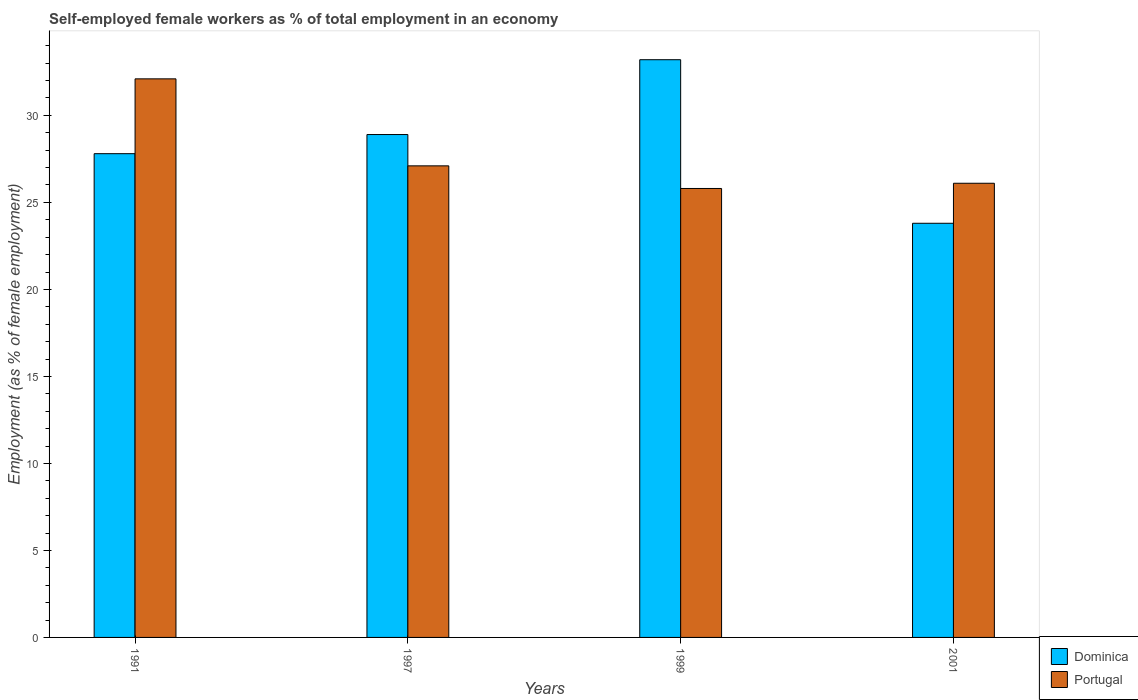Are the number of bars per tick equal to the number of legend labels?
Keep it short and to the point. Yes. Are the number of bars on each tick of the X-axis equal?
Provide a succinct answer. Yes. How many bars are there on the 2nd tick from the left?
Provide a succinct answer. 2. What is the label of the 3rd group of bars from the left?
Provide a succinct answer. 1999. What is the percentage of self-employed female workers in Dominica in 1997?
Offer a very short reply. 28.9. Across all years, what is the maximum percentage of self-employed female workers in Portugal?
Your response must be concise. 32.1. Across all years, what is the minimum percentage of self-employed female workers in Portugal?
Provide a short and direct response. 25.8. In which year was the percentage of self-employed female workers in Dominica minimum?
Offer a very short reply. 2001. What is the total percentage of self-employed female workers in Portugal in the graph?
Give a very brief answer. 111.1. What is the difference between the percentage of self-employed female workers in Portugal in 1991 and that in 1999?
Offer a terse response. 6.3. What is the difference between the percentage of self-employed female workers in Dominica in 1997 and the percentage of self-employed female workers in Portugal in 2001?
Keep it short and to the point. 2.8. What is the average percentage of self-employed female workers in Portugal per year?
Make the answer very short. 27.77. In the year 2001, what is the difference between the percentage of self-employed female workers in Dominica and percentage of self-employed female workers in Portugal?
Provide a succinct answer. -2.3. In how many years, is the percentage of self-employed female workers in Portugal greater than 2 %?
Keep it short and to the point. 4. What is the ratio of the percentage of self-employed female workers in Dominica in 1999 to that in 2001?
Offer a terse response. 1.39. Is the percentage of self-employed female workers in Portugal in 1997 less than that in 2001?
Keep it short and to the point. No. What is the difference between the highest and the second highest percentage of self-employed female workers in Portugal?
Provide a short and direct response. 5. What is the difference between the highest and the lowest percentage of self-employed female workers in Portugal?
Make the answer very short. 6.3. Is the sum of the percentage of self-employed female workers in Dominica in 1991 and 1997 greater than the maximum percentage of self-employed female workers in Portugal across all years?
Keep it short and to the point. Yes. What does the 2nd bar from the right in 1997 represents?
Provide a succinct answer. Dominica. How many bars are there?
Keep it short and to the point. 8. Are all the bars in the graph horizontal?
Provide a succinct answer. No. Are the values on the major ticks of Y-axis written in scientific E-notation?
Provide a succinct answer. No. Does the graph contain any zero values?
Provide a short and direct response. No. Does the graph contain grids?
Provide a short and direct response. No. Where does the legend appear in the graph?
Offer a terse response. Bottom right. How many legend labels are there?
Provide a short and direct response. 2. What is the title of the graph?
Offer a terse response. Self-employed female workers as % of total employment in an economy. Does "Armenia" appear as one of the legend labels in the graph?
Your answer should be very brief. No. What is the label or title of the X-axis?
Offer a very short reply. Years. What is the label or title of the Y-axis?
Make the answer very short. Employment (as % of female employment). What is the Employment (as % of female employment) of Dominica in 1991?
Offer a terse response. 27.8. What is the Employment (as % of female employment) of Portugal in 1991?
Your response must be concise. 32.1. What is the Employment (as % of female employment) of Dominica in 1997?
Provide a succinct answer. 28.9. What is the Employment (as % of female employment) of Portugal in 1997?
Make the answer very short. 27.1. What is the Employment (as % of female employment) of Dominica in 1999?
Ensure brevity in your answer.  33.2. What is the Employment (as % of female employment) of Portugal in 1999?
Provide a short and direct response. 25.8. What is the Employment (as % of female employment) in Dominica in 2001?
Your answer should be very brief. 23.8. What is the Employment (as % of female employment) in Portugal in 2001?
Provide a short and direct response. 26.1. Across all years, what is the maximum Employment (as % of female employment) of Dominica?
Your response must be concise. 33.2. Across all years, what is the maximum Employment (as % of female employment) in Portugal?
Ensure brevity in your answer.  32.1. Across all years, what is the minimum Employment (as % of female employment) of Dominica?
Ensure brevity in your answer.  23.8. Across all years, what is the minimum Employment (as % of female employment) in Portugal?
Keep it short and to the point. 25.8. What is the total Employment (as % of female employment) in Dominica in the graph?
Keep it short and to the point. 113.7. What is the total Employment (as % of female employment) of Portugal in the graph?
Offer a terse response. 111.1. What is the difference between the Employment (as % of female employment) of Dominica in 1991 and that in 1999?
Ensure brevity in your answer.  -5.4. What is the difference between the Employment (as % of female employment) of Portugal in 1991 and that in 1999?
Provide a short and direct response. 6.3. What is the difference between the Employment (as % of female employment) in Dominica in 1991 and that in 2001?
Offer a very short reply. 4. What is the difference between the Employment (as % of female employment) of Portugal in 1991 and that in 2001?
Provide a short and direct response. 6. What is the difference between the Employment (as % of female employment) in Dominica in 1997 and that in 1999?
Your answer should be compact. -4.3. What is the difference between the Employment (as % of female employment) of Portugal in 1997 and that in 1999?
Your response must be concise. 1.3. What is the difference between the Employment (as % of female employment) of Dominica in 1991 and the Employment (as % of female employment) of Portugal in 1999?
Your response must be concise. 2. What is the difference between the Employment (as % of female employment) of Dominica in 1997 and the Employment (as % of female employment) of Portugal in 1999?
Provide a succinct answer. 3.1. What is the difference between the Employment (as % of female employment) in Dominica in 1997 and the Employment (as % of female employment) in Portugal in 2001?
Give a very brief answer. 2.8. What is the difference between the Employment (as % of female employment) of Dominica in 1999 and the Employment (as % of female employment) of Portugal in 2001?
Offer a very short reply. 7.1. What is the average Employment (as % of female employment) in Dominica per year?
Your answer should be very brief. 28.43. What is the average Employment (as % of female employment) in Portugal per year?
Your response must be concise. 27.77. In the year 1991, what is the difference between the Employment (as % of female employment) in Dominica and Employment (as % of female employment) in Portugal?
Offer a very short reply. -4.3. What is the ratio of the Employment (as % of female employment) of Dominica in 1991 to that in 1997?
Provide a short and direct response. 0.96. What is the ratio of the Employment (as % of female employment) of Portugal in 1991 to that in 1997?
Ensure brevity in your answer.  1.18. What is the ratio of the Employment (as % of female employment) of Dominica in 1991 to that in 1999?
Your answer should be very brief. 0.84. What is the ratio of the Employment (as % of female employment) of Portugal in 1991 to that in 1999?
Keep it short and to the point. 1.24. What is the ratio of the Employment (as % of female employment) of Dominica in 1991 to that in 2001?
Provide a succinct answer. 1.17. What is the ratio of the Employment (as % of female employment) of Portugal in 1991 to that in 2001?
Make the answer very short. 1.23. What is the ratio of the Employment (as % of female employment) in Dominica in 1997 to that in 1999?
Your answer should be very brief. 0.87. What is the ratio of the Employment (as % of female employment) in Portugal in 1997 to that in 1999?
Give a very brief answer. 1.05. What is the ratio of the Employment (as % of female employment) of Dominica in 1997 to that in 2001?
Your answer should be very brief. 1.21. What is the ratio of the Employment (as % of female employment) of Portugal in 1997 to that in 2001?
Give a very brief answer. 1.04. What is the ratio of the Employment (as % of female employment) in Dominica in 1999 to that in 2001?
Keep it short and to the point. 1.4. What is the ratio of the Employment (as % of female employment) in Portugal in 1999 to that in 2001?
Offer a very short reply. 0.99. What is the difference between the highest and the second highest Employment (as % of female employment) in Portugal?
Your answer should be compact. 5. What is the difference between the highest and the lowest Employment (as % of female employment) of Portugal?
Offer a terse response. 6.3. 